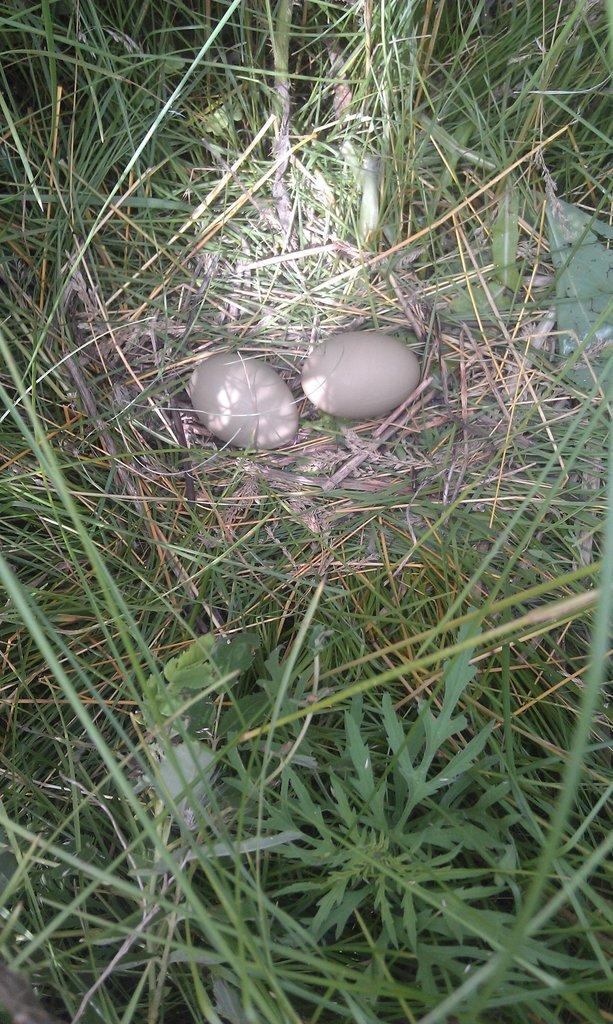What type of food item can be seen in the image? There are eggs in the image. What type of vegetation is present in the image? There is grass in the image. What type of quiver is visible in the image? There is no quiver present in the image. What type of soda is being poured into the glass in the image? There is no glass or soda present in the image. 